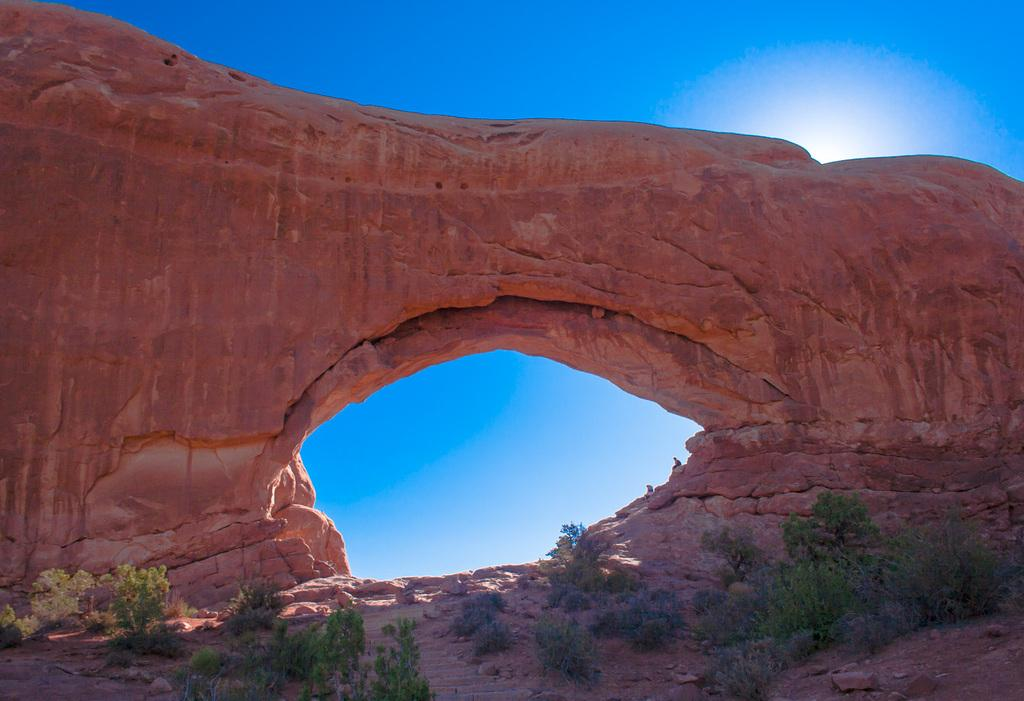What structure is present in the image? There is an arch in the image. What is located in front of the arch? There are plants in front of the arch. What can be seen in the background of the image? The sky is visible in the background of the image. What type of food is hanging from the arch in the image? There is no food present in the image, and nothing is hanging from the arch. 